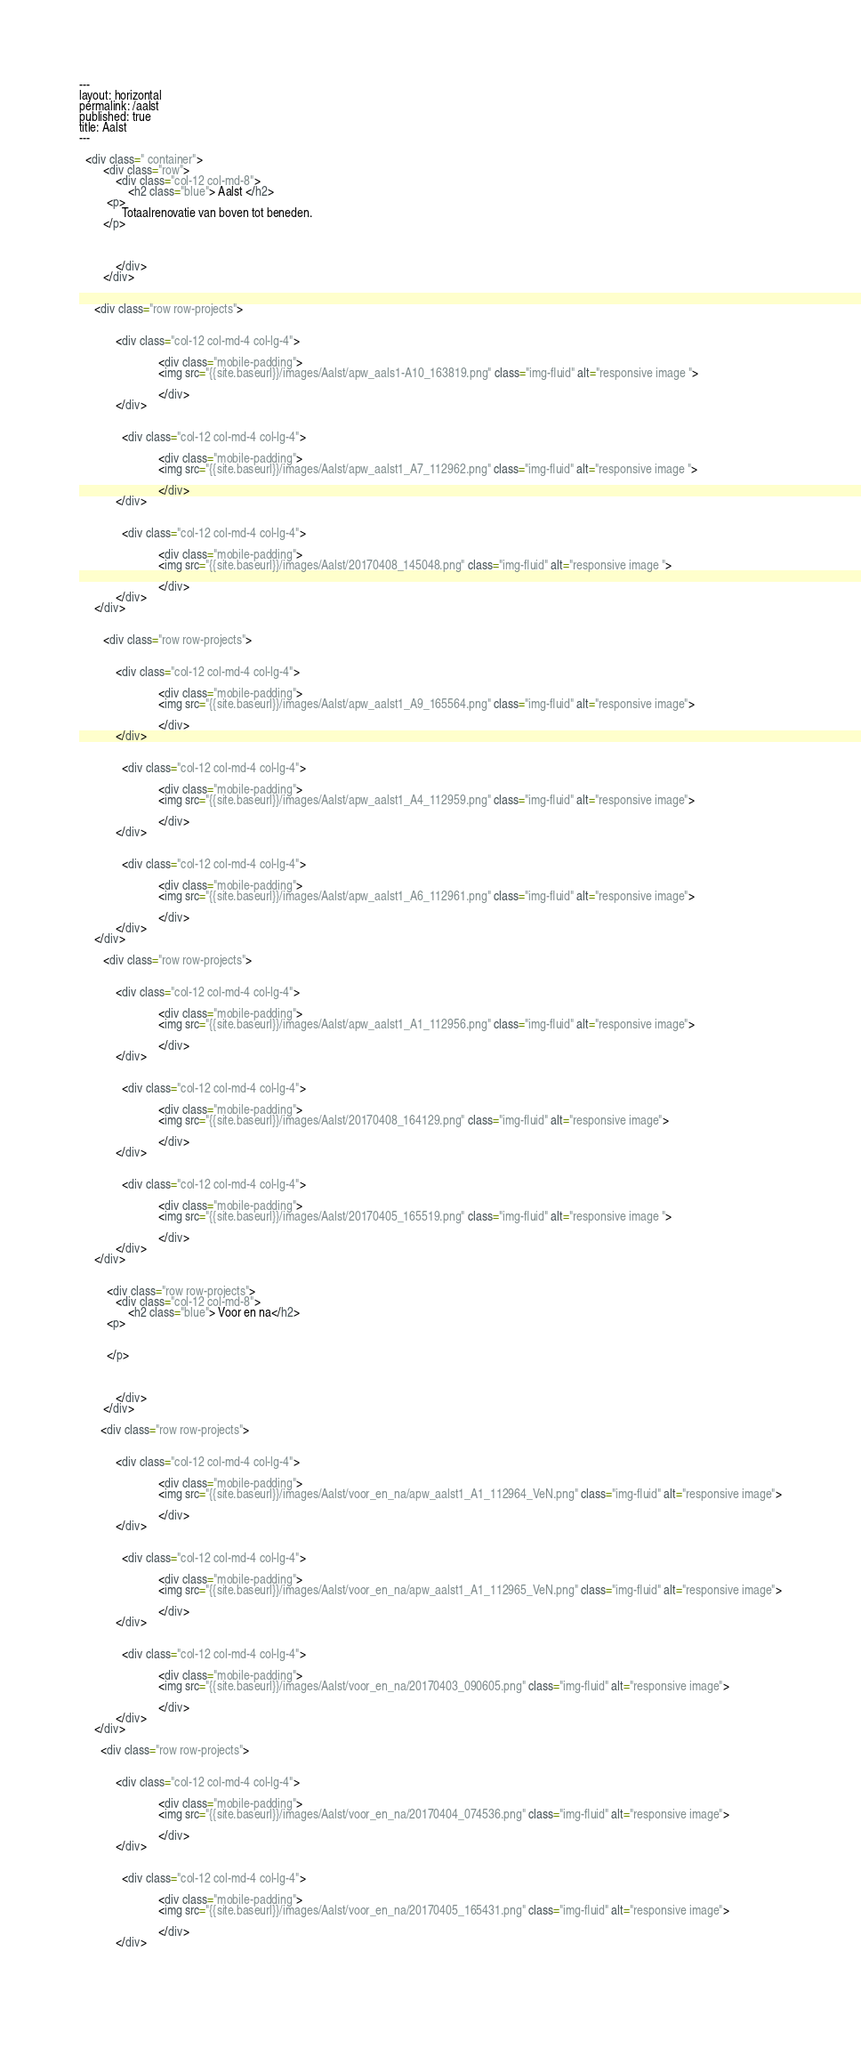<code> <loc_0><loc_0><loc_500><loc_500><_HTML_>---
layout: horizontal
permalink: /aalst
published: true
title: Aalst
---

  <div class=" container">
        <div class="row">
            <div class="col-12 col-md-8">
                <h2 class="blue"> Aalst </h2>
         <p>
              Totaalrenovatie van boven tot beneden.
        </p>


            
            </div>
        </div>


     <div class="row row-projects">
            
           
            <div class="col-12 col-md-4 col-lg-4">
               
                          <div class="mobile-padding">
                          <img src="{{site.baseurl}}/images/Aalst/apw_aals1-A10_163819.png" class="img-fluid" alt="responsive image ">
                        
                          </div>
            </div>
         
         
              <div class="col-12 col-md-4 col-lg-4">
               
                          <div class="mobile-padding">
                          <img src="{{site.baseurl}}/images/Aalst/apw_aalst1_A7_112962.png" class="img-fluid" alt="responsive image ">
                        
                          </div>
            </div>
         
         
              <div class="col-12 col-md-4 col-lg-4">
               
                          <div class="mobile-padding">
                          <img src="{{site.baseurl}}/images/Aalst/20170408_145048.png" class="img-fluid" alt="responsive image ">
                        
                          </div>
            </div>
     </div>
      
      
        <div class="row row-projects">
            
           
            <div class="col-12 col-md-4 col-lg-4">
               
                          <div class="mobile-padding">
                          <img src="{{site.baseurl}}/images/Aalst/apw_aalst1_A9_165564.png" class="img-fluid" alt="responsive image">
                        
                          </div>
            </div>
         
         
              <div class="col-12 col-md-4 col-lg-4">
               
                          <div class="mobile-padding">
                          <img src="{{site.baseurl}}/images/Aalst/apw_aalst1_A4_112959.png" class="img-fluid" alt="responsive image">
                        
                          </div>
            </div>
         
         
              <div class="col-12 col-md-4 col-lg-4">
               
                          <div class="mobile-padding">
                          <img src="{{site.baseurl}}/images/Aalst/apw_aalst1_A6_112961.png" class="img-fluid" alt="responsive image">
                        
                          </div>
            </div>
     </div>
      
        <div class="row row-projects">
            
           
            <div class="col-12 col-md-4 col-lg-4">
               
                          <div class="mobile-padding">
                          <img src="{{site.baseurl}}/images/Aalst/apw_aalst1_A1_112956.png" class="img-fluid" alt="responsive image">
                        
                          </div>
            </div>
         
         
              <div class="col-12 col-md-4 col-lg-4">
               
                          <div class="mobile-padding">
                          <img src="{{site.baseurl}}/images/Aalst/20170408_164129.png" class="img-fluid" alt="responsive image">
                        
                          </div>
            </div>
         
         
              <div class="col-12 col-md-4 col-lg-4">
               
                          <div class="mobile-padding">
                          <img src="{{site.baseurl}}/images/Aalst/20170405_165519.png" class="img-fluid" alt="responsive image ">
                        
                          </div>
            </div>
     </div>
      
    
         <div class="row row-projects">
            <div class="col-12 col-md-8">
                <h2 class="blue"> Voor en na</h2>
         <p>
             
             
         </p>


            
            </div>
        </div>
      
       <div class="row row-projects">
            
           
            <div class="col-12 col-md-4 col-lg-4">
               
                          <div class="mobile-padding">
                          <img src="{{site.baseurl}}/images/Aalst/voor_en_na/apw_aalst1_A1_112964_VeN.png" class="img-fluid" alt="responsive image">
                        
                          </div>
            </div>
         
         
              <div class="col-12 col-md-4 col-lg-4">
               
                          <div class="mobile-padding">
                          <img src="{{site.baseurl}}/images/Aalst/voor_en_na/apw_aalst1_A1_112965_VeN.png" class="img-fluid" alt="responsive image">
                        
                          </div>
            </div>
         
         
              <div class="col-12 col-md-4 col-lg-4">
               
                          <div class="mobile-padding">
                          <img src="{{site.baseurl}}/images/Aalst/voor_en_na/20170403_090605.png" class="img-fluid" alt="responsive image">
                        
                          </div>
            </div>
     </div>
      
       <div class="row row-projects">
            
           
            <div class="col-12 col-md-4 col-lg-4">
               
                          <div class="mobile-padding">
                          <img src="{{site.baseurl}}/images/Aalst/voor_en_na/20170404_074536.png" class="img-fluid" alt="responsive image">
                        
                          </div>
            </div>
         
         
              <div class="col-12 col-md-4 col-lg-4">
               
                          <div class="mobile-padding">
                          <img src="{{site.baseurl}}/images/Aalst/voor_en_na/20170405_165431.png" class="img-fluid" alt="responsive image">
                        
                          </div>
            </div>
         
         </code> 